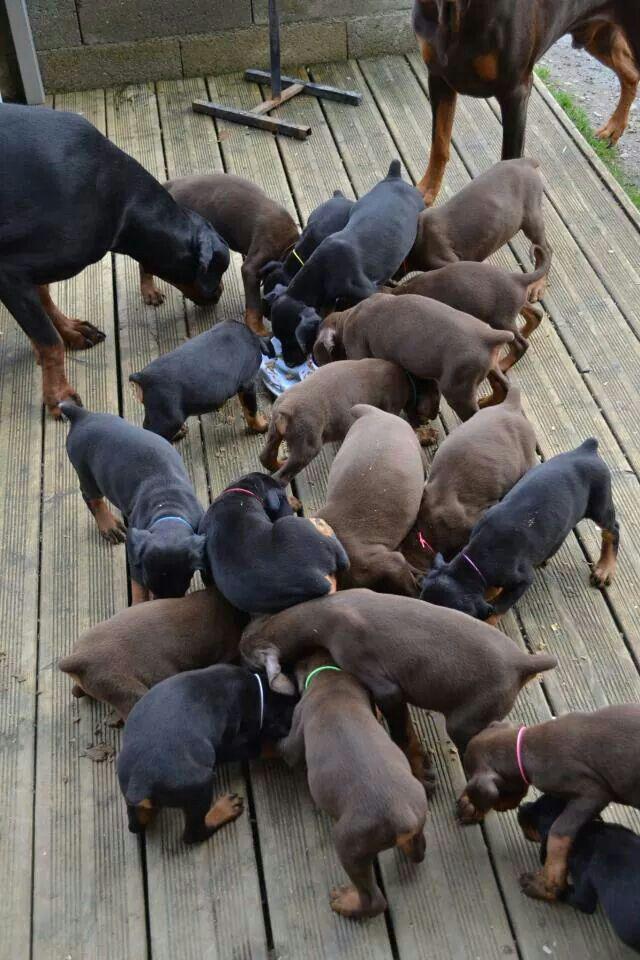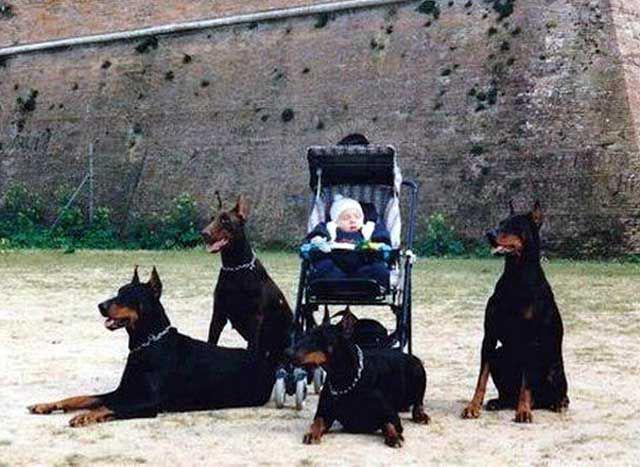The first image is the image on the left, the second image is the image on the right. Assess this claim about the two images: "An image shows a person at the center of an outdoor scene, surrounded by a group of pointy-eared adult dobermans wearing collars.". Correct or not? Answer yes or no. Yes. The first image is the image on the left, the second image is the image on the right. Analyze the images presented: Is the assertion "There are more dogs in the left image than in the right image." valid? Answer yes or no. Yes. 